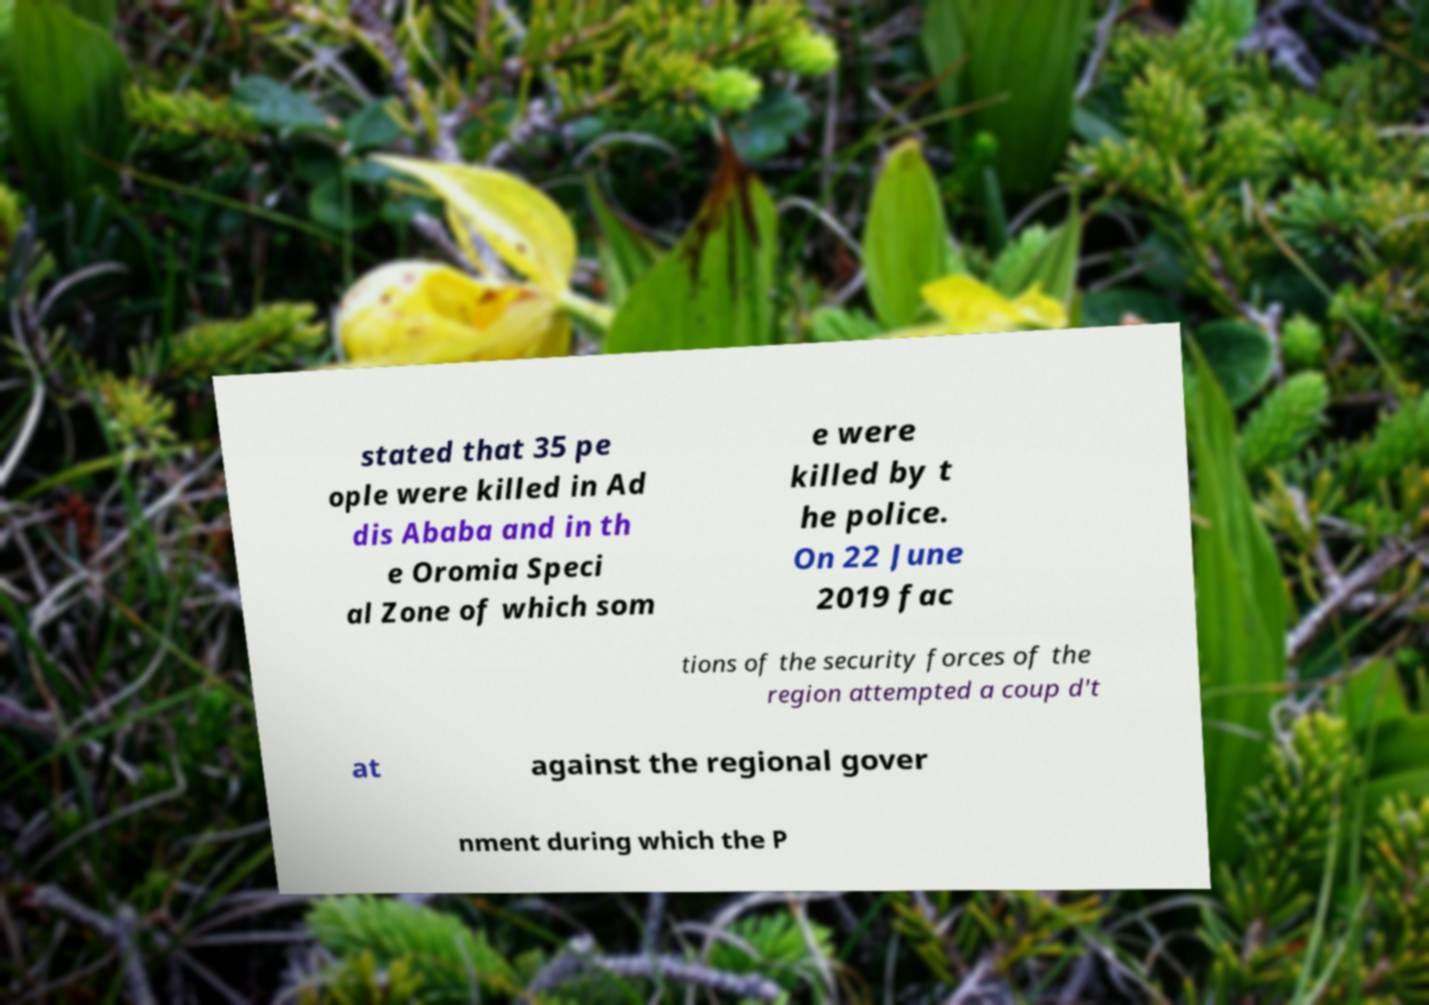Could you extract and type out the text from this image? stated that 35 pe ople were killed in Ad dis Ababa and in th e Oromia Speci al Zone of which som e were killed by t he police. On 22 June 2019 fac tions of the security forces of the region attempted a coup d't at against the regional gover nment during which the P 